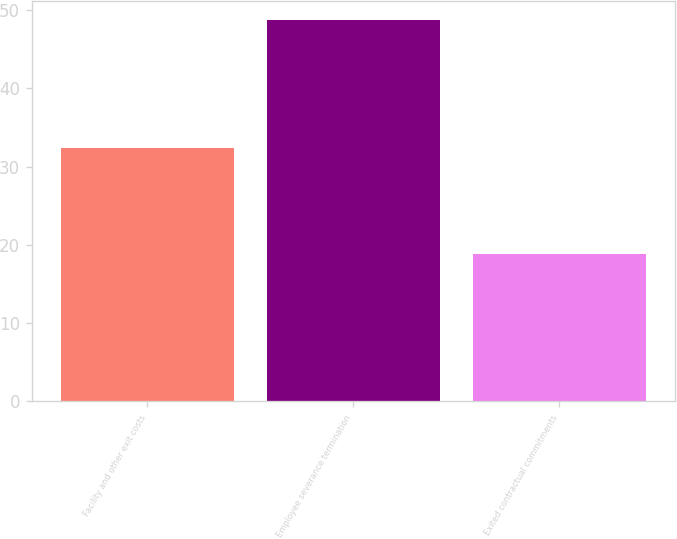Convert chart. <chart><loc_0><loc_0><loc_500><loc_500><bar_chart><fcel>Facility and other exit costs<fcel>Employee severance termination<fcel>Exited contractual commitments<nl><fcel>32.4<fcel>48.8<fcel>18.8<nl></chart> 